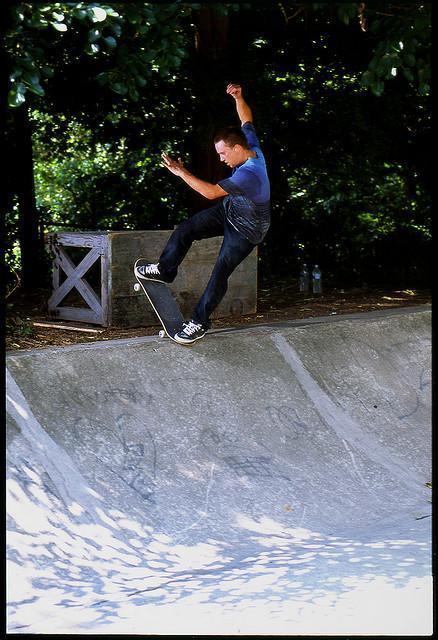How many people are in this picture?
Give a very brief answer. 1. How many people have skateboards?
Give a very brief answer. 1. 